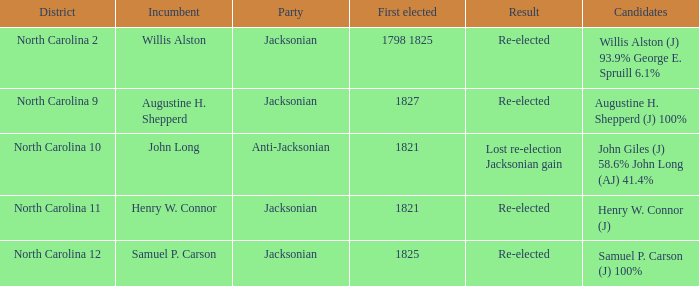State the conclusion for augustine h. shepperd (j) with 100% completion. Re-elected. 